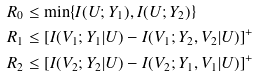Convert formula to latex. <formula><loc_0><loc_0><loc_500><loc_500>R _ { 0 } & \leq \min \{ I ( U ; Y _ { 1 } ) , I ( U ; Y _ { 2 } ) \} \\ R _ { 1 } & \leq \left [ I ( V _ { 1 } ; Y _ { 1 } | U ) - I ( V _ { 1 } ; Y _ { 2 } , V _ { 2 } | U ) \right ] ^ { + } \\ R _ { 2 } & \leq \left [ I ( V _ { 2 } ; Y _ { 2 } | U ) - I ( V _ { 2 } ; Y _ { 1 } , V _ { 1 } | U ) \right ] ^ { + }</formula> 